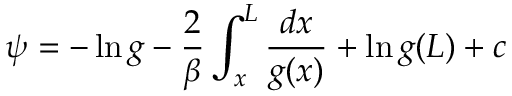Convert formula to latex. <formula><loc_0><loc_0><loc_500><loc_500>\psi = - \ln g - { \frac { 2 } { \beta } } \int _ { x } ^ { L } { \frac { d x } { g ( x ) } } + \ln g ( L ) + c</formula> 